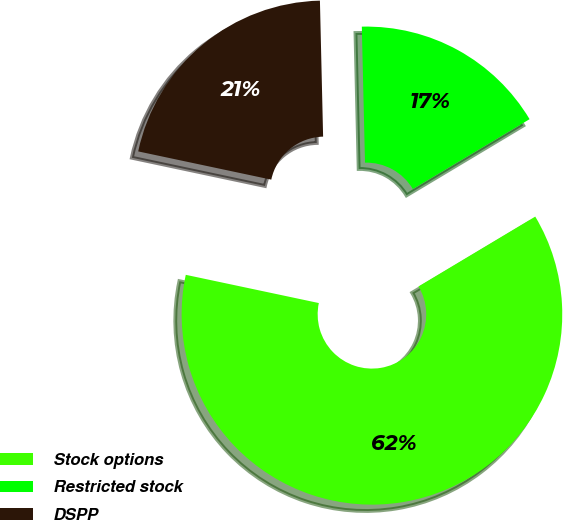Convert chart to OTSL. <chart><loc_0><loc_0><loc_500><loc_500><pie_chart><fcel>Stock options<fcel>Restricted stock<fcel>DSPP<nl><fcel>61.91%<fcel>16.79%<fcel>21.3%<nl></chart> 